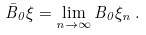Convert formula to latex. <formula><loc_0><loc_0><loc_500><loc_500>\bar { B } _ { 0 } \xi = \lim _ { n \rightarrow \infty } B _ { 0 } \xi _ { n } \, .</formula> 